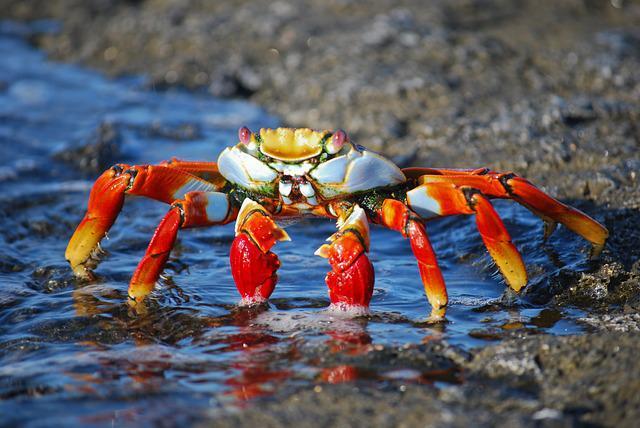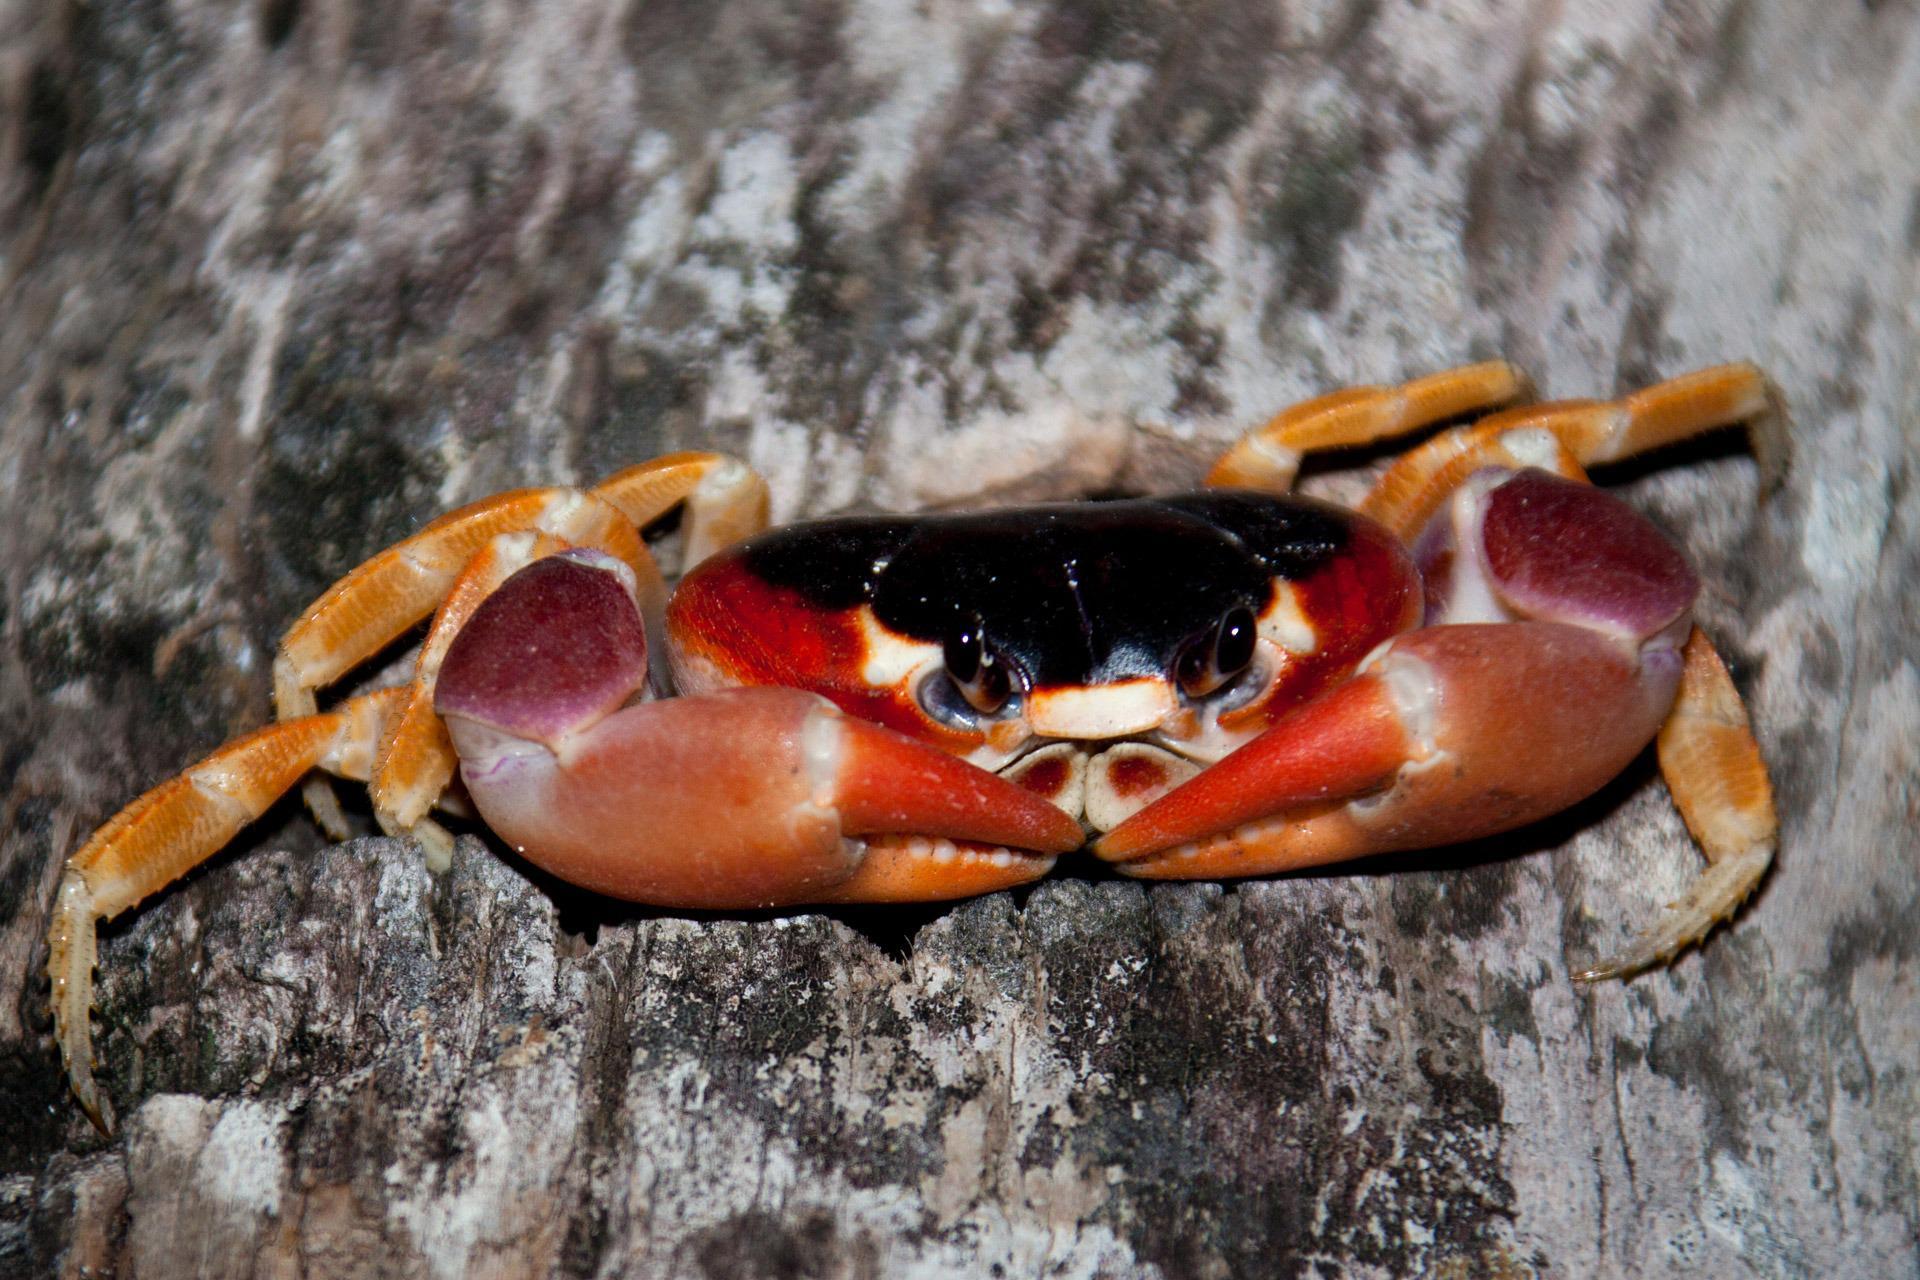The first image is the image on the left, the second image is the image on the right. For the images displayed, is the sentence "The righthand image shows a blue-and-yellow faced crab with its two red front claws turned downward and perched on rock." factually correct? Answer yes or no. No. The first image is the image on the left, the second image is the image on the right. Assess this claim about the two images: "The left and right image contains the same number of crabs standing on land.". Correct or not? Answer yes or no. No. 